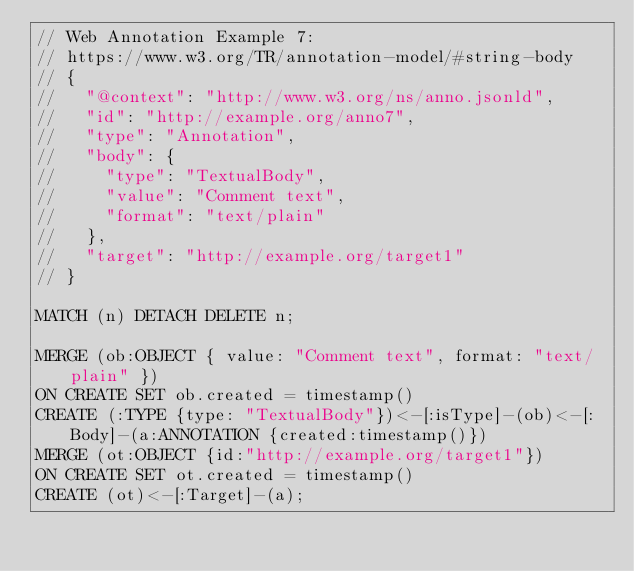<code> <loc_0><loc_0><loc_500><loc_500><_SQL_>// Web Annotation Example 7:
// https://www.w3.org/TR/annotation-model/#string-body
// {
//   "@context": "http://www.w3.org/ns/anno.jsonld",
//   "id": "http://example.org/anno7",
//   "type": "Annotation",
//   "body": {
//     "type": "TextualBody",
//     "value": "Comment text",
//     "format": "text/plain"
//   },
//   "target": "http://example.org/target1"
// }

MATCH (n) DETACH DELETE n;

MERGE (ob:OBJECT { value: "Comment text", format: "text/plain" })
ON CREATE SET ob.created = timestamp()
CREATE (:TYPE {type: "TextualBody"})<-[:isType]-(ob)<-[:Body]-(a:ANNOTATION {created:timestamp()})
MERGE (ot:OBJECT {id:"http://example.org/target1"})
ON CREATE SET ot.created = timestamp()
CREATE (ot)<-[:Target]-(a);
</code> 